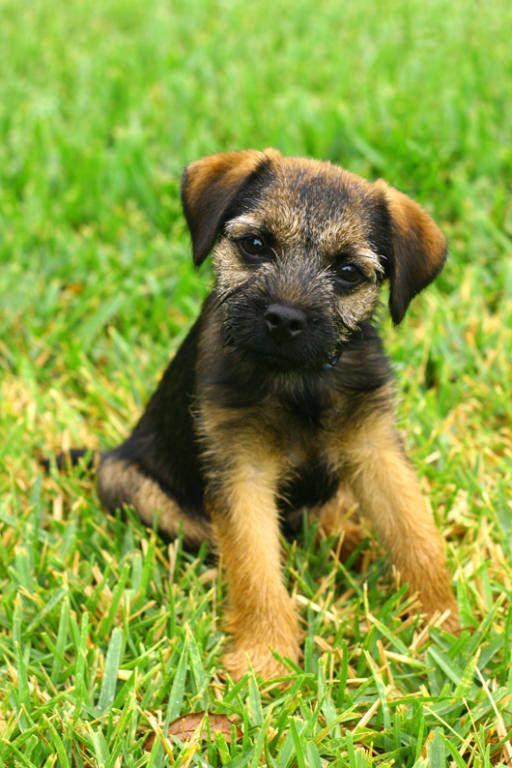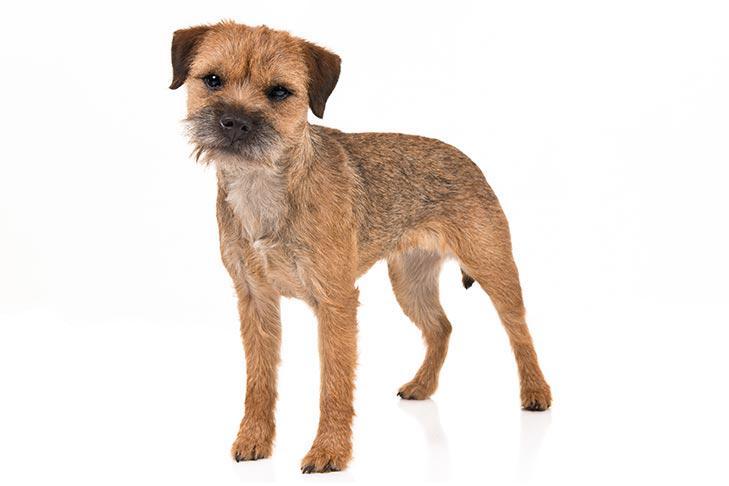The first image is the image on the left, the second image is the image on the right. Analyze the images presented: Is the assertion "One of the dogs is a puppy, and the other is in his middle years; you can visually verify their ages easily." valid? Answer yes or no. Yes. The first image is the image on the left, the second image is the image on the right. Assess this claim about the two images: "Every image shows exactly one dog, and in images where the dog is standing outside in grass the dog is facing the left.". Correct or not? Answer yes or no. No. 